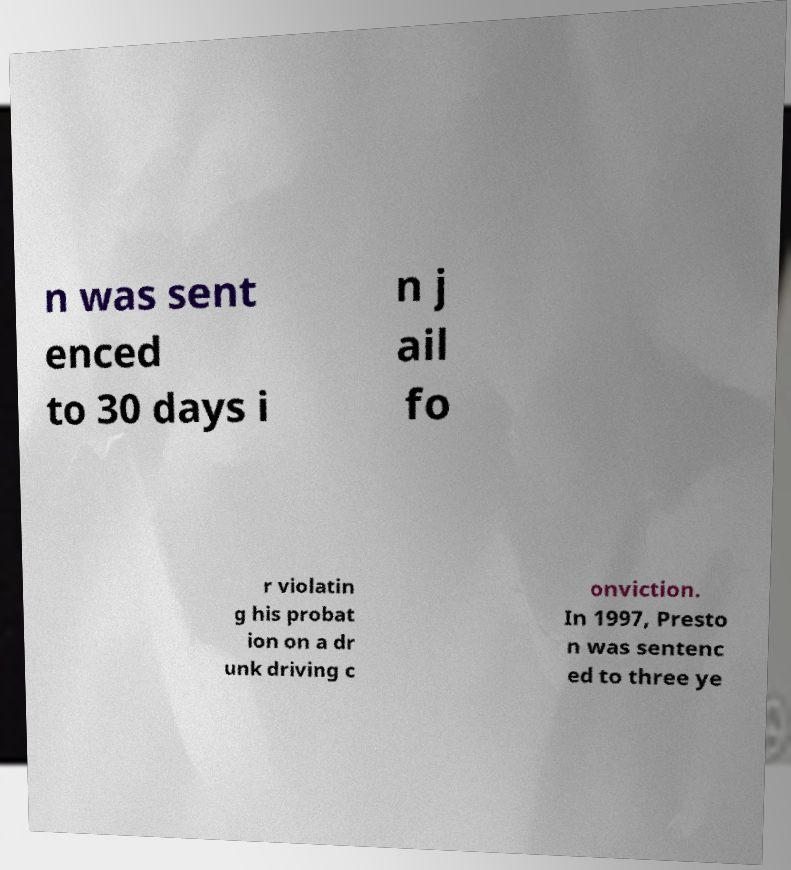Please identify and transcribe the text found in this image. n was sent enced to 30 days i n j ail fo r violatin g his probat ion on a dr unk driving c onviction. In 1997, Presto n was sentenc ed to three ye 